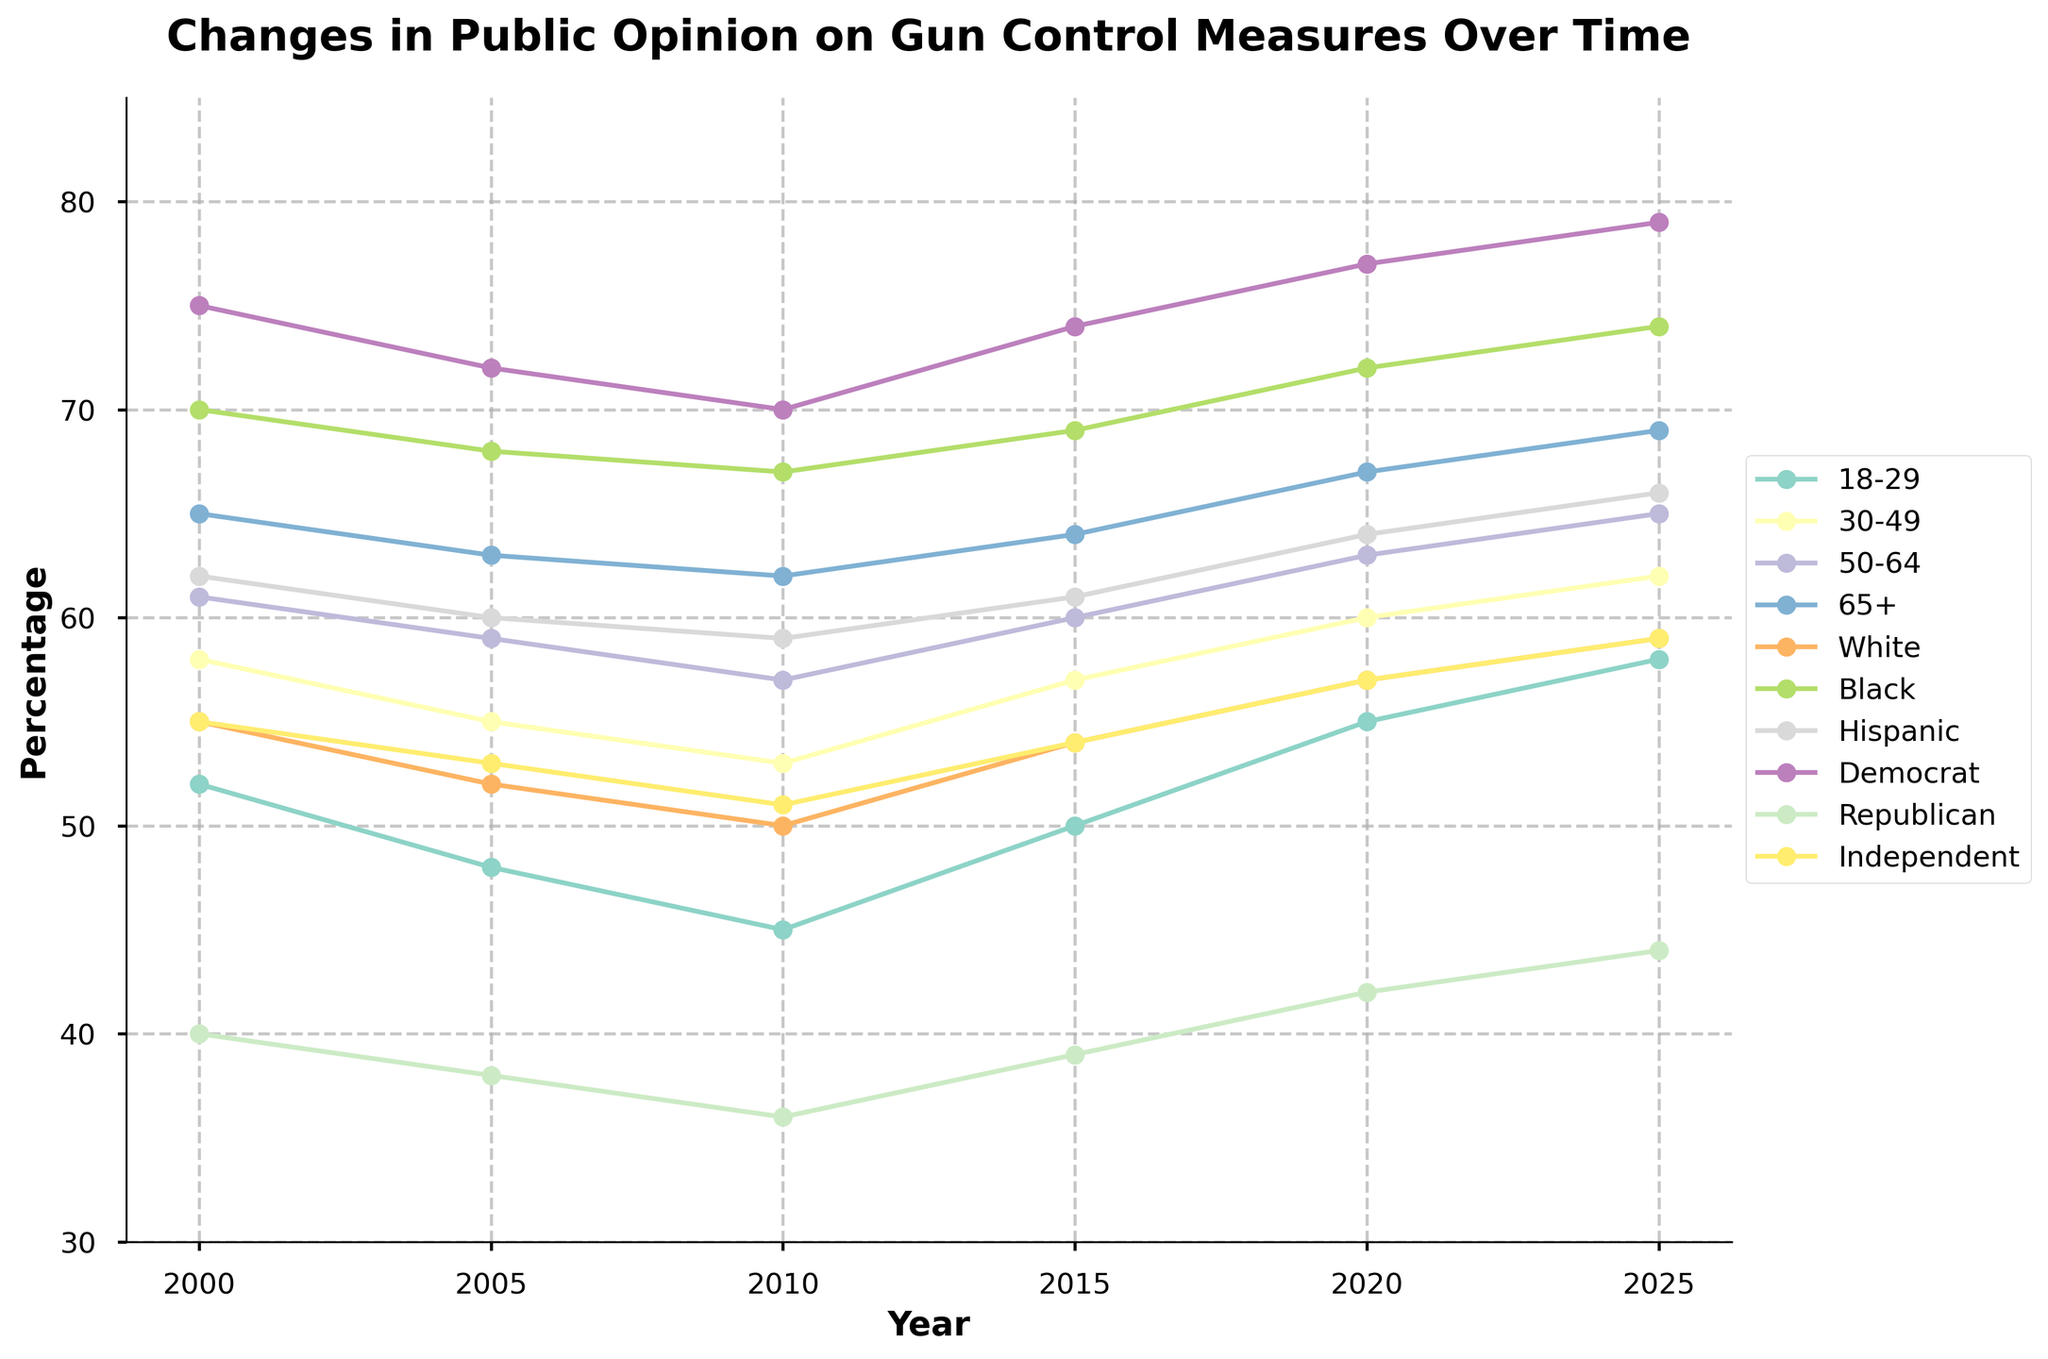What's the overall trend in public opinion on gun control measures across all age groups between 2000 and 2025? Look at the lines representing each age group from 2000 to 2025. They show an upward trend, indicating an increase in the percentage of people supporting gun control measures over time.
Answer: Upward trend Which demographic group shows the highest support for gun control measures in the year 2025? In 2025, the demographic group with the highest line on the chart indicates the highest support. The Black demographic shows the highest support at around 74%.
Answer: Black How does the support for gun control in the 18-29 age group in 2020 compare to 2000? Compare the values for the 18-29 age group in the years 2000 and 2020. In 2000, it was 52%, and in 2020, it was 55%, showing an increase.
Answer: Increased by 3% Which political affiliation shows the most significant change in support for gun control measures from 2000 to 2025? Calculate the difference in percentages for each political affiliation between 2000 and 2025. Democrats increased from 75% to 79%, Republicans from 40% to 44%, and Independents from 55% to 59%. The Republican group's support has the most substantial change (4%).
Answer: Republican (increased by 4%) What's the average support for gun control measures across all age groups in 2025? Sum the values for all age groups in 2025 and divide by the number of age groups: (58 + 62 + 65 + 69) / 4. The sum is 254, and the average is 254/4 = 63.5%.
Answer: 63.5% Between which years does the 30-49 age group show the highest increase in support for gun control measures? Compare the differences between each period for the 30-49 age group. The increases are: 2000-2005 (-3%), 2005-2010 (-2%), 2010-2015 (+4%), 2015-2020 (+3%), and 2020-2025 (+2%). The highest increase is from 2010 to 2015.
Answer: 2010 to 2015 Which racial group consistently shows more support for gun control measures than the White group over the years? Compare the Black and Hispanic lines to the White line for all years. Both racial groups show consistently higher support throughout the years.
Answer: Black and Hispanic Comparing the support change in the Hispanic demographic between 2010 and 2025, how much did it increase? Subtract the percentage in 2010 from the percentage in 2025 for the Hispanic demographic: 66% - 59% = 7%.
Answer: Increased by 7% In 2015, how much higher is the support for gun control measures among Democrats compared to Republicans? Subtract the percentage of Republicans from Democrats in 2015: 74% - 39% = 35%.
Answer: 35% higher Which age group shows the least support for gun control measures in 2005? Identify the lowest line among all age groups in 2005. The 18-29 age group shows the least support with 48%.
Answer: 18-29 